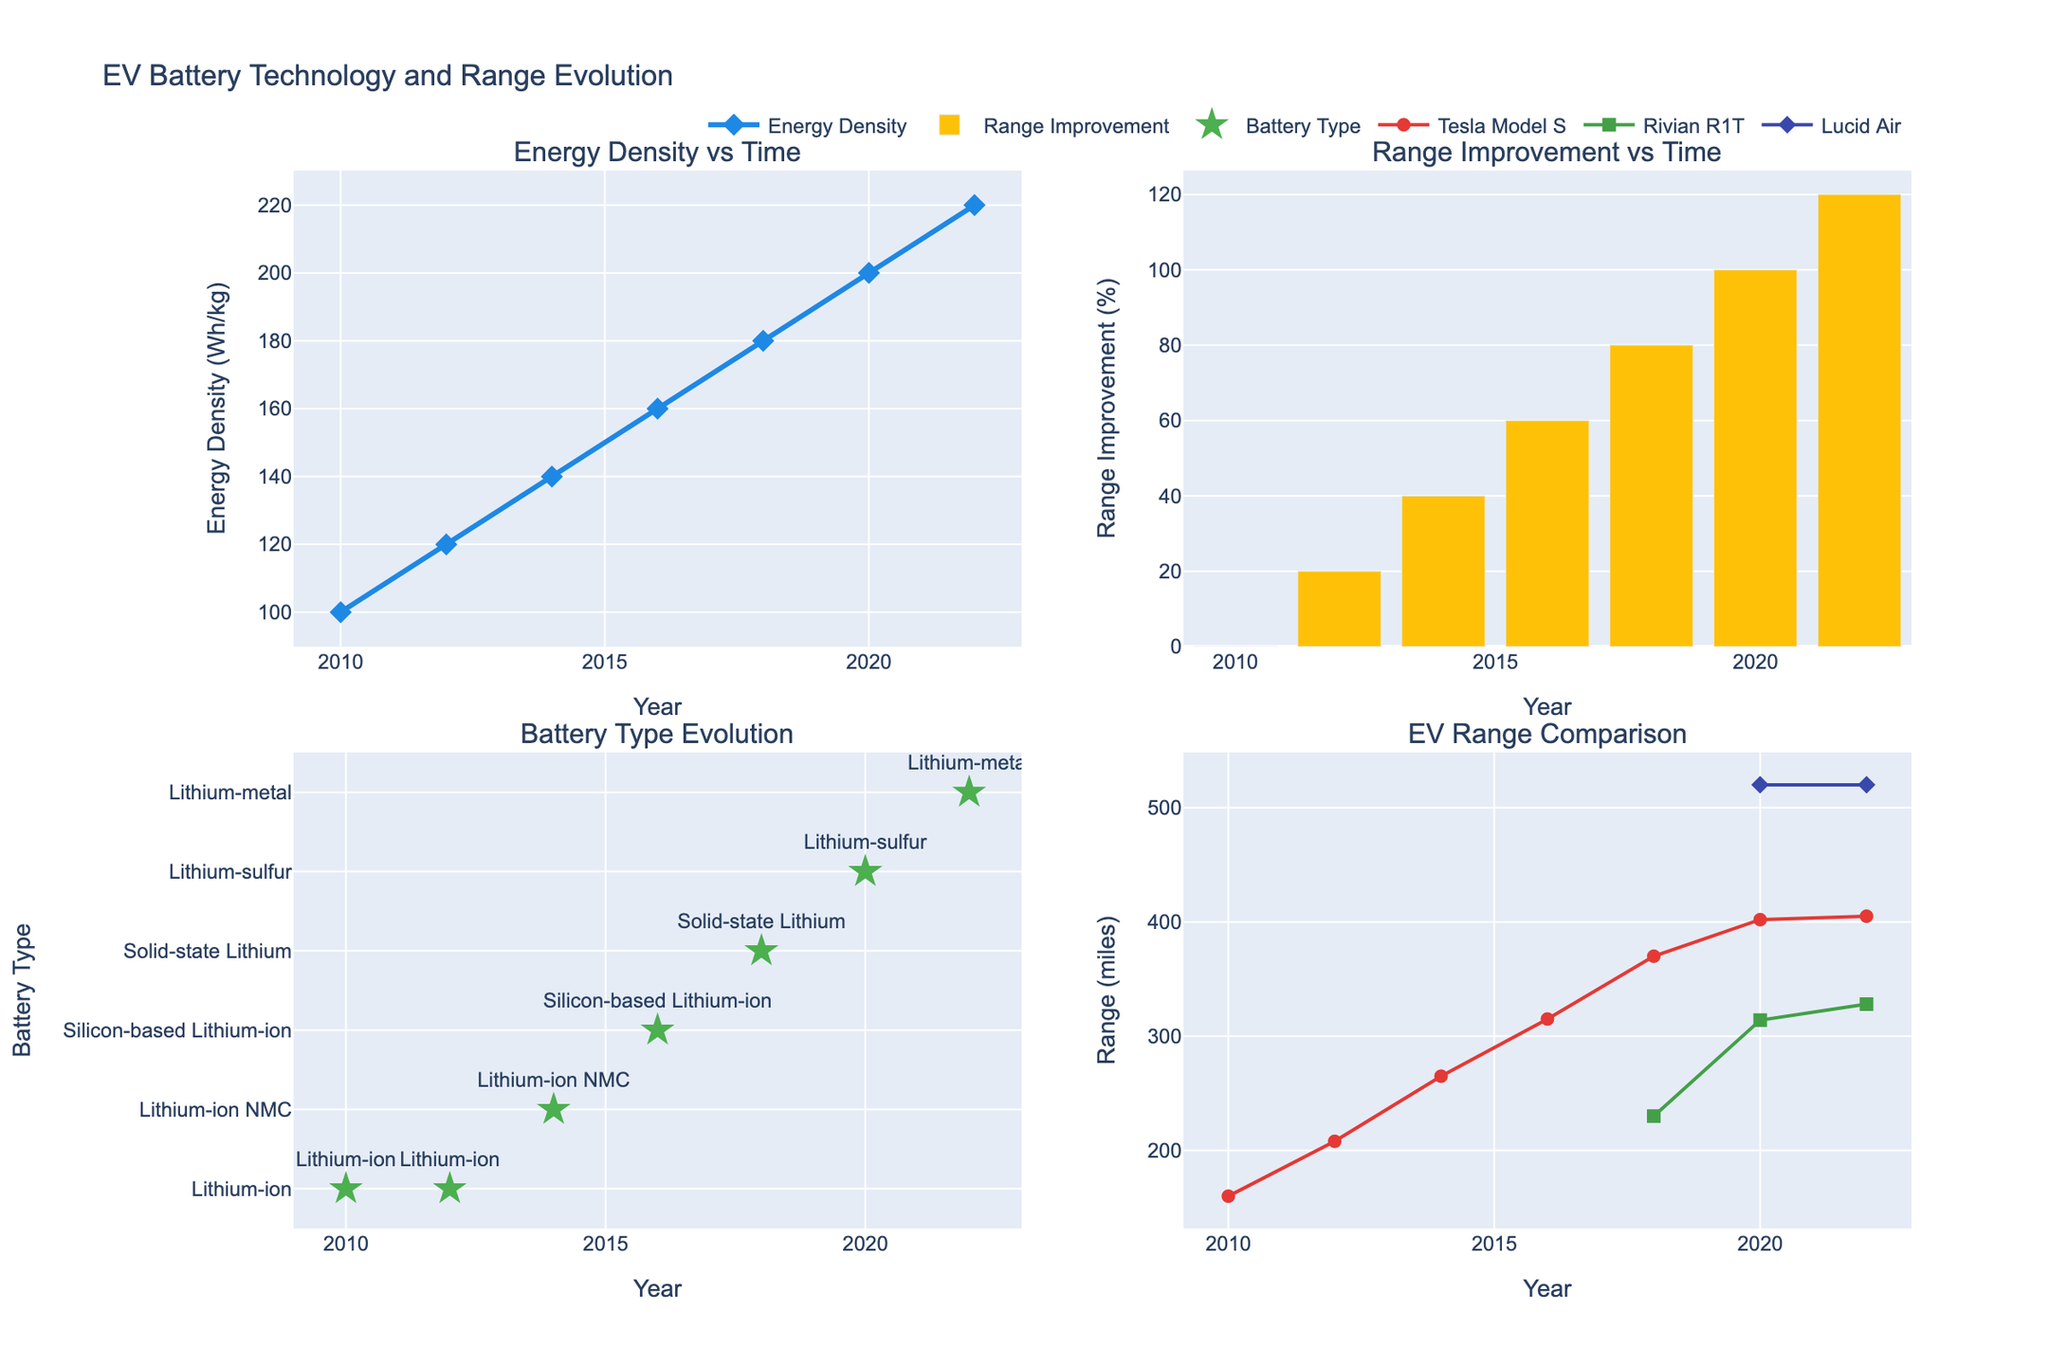Which country has the highest Non-Indigenous life expectancy? Look at the bar chart on the left. The tallest bar for Non-Indigenous life expectancy is for Australia, which indicates that Australia has the highest Non-Indigenous life expectancy.
Answer: Australia Which country has the smallest gap in life expectancy between Indigenous and Non-Indigenous populations? Refer to the scatter plot on the right. The country with the smallest gap is Bolivia, as indicated by the lowest marker value.
Answer: Bolivia How does Indigenous life expectancy in Canada compare to Indigenous life expectancy in New Zealand? Compare the bars for Indigenous life expectancy between Canada and New Zealand on the left chart. Canada's bar is slightly lower than that of New Zealand, indicating a lower life expectancy for Indigenous populations in Canada.
Answer: Lower What is the life expectancy gap in Peru? Look at the scatter plot on the right and refer to the marker for Peru. The gap is shown next to the marker and is approximately 3.9 years.
Answer: 3.9 years Which country has the largest difference in life expectancy between Indigenous and Non-Indigenous populations? The scatter plot on the right gives the largest gap. The highest marker is for Australia, indicating the largest difference.
Answer: Australia What are the Indigenous and Non-Indigenous life expectancies in Chile? Look at the bar chart on the left for Chile. The Indigenous life expectancy is around 71.9 years, and the Non-Indigenous life expectancy is around 80.2 years.
Answer: 71.9 years, 80.2 years Which country shows a higher life expectancy for both Indigenous and Non-Indigenous populations compared to the United States? Refer to the bars representing life expectancy for both populations. Canada, New Zealand, Chile, and Australia all have higher life expectancies for both groups compared to the United States.
Answer: Canada, New Zealand, Chile, Australia Is the life expectancy gap in Guatemala larger than in Bolivia? Compare the markers for Guatemala and Bolivia in the scatter plot on the right. Guatemala's marker is higher than Bolivia's, indicating a larger gap.
Answer: Yes What is the average life expectancy gap across all listed countries? Sum the gaps from the scatter plot: (82.4-71.6) + (82.0-72.8) + (81.9-73.4) + (78.9-71.1) + (75.7-66.2) + (77.3-69.5) + (73.8-64.7) + (76.5-72.6) + (80.2-71.9) + (71.5-65.3) = 127.3. Divide by the number of countries (10) to get the average: 127.3/10 = 12.73/10 = 12.73.
Answer: 7.98 years 